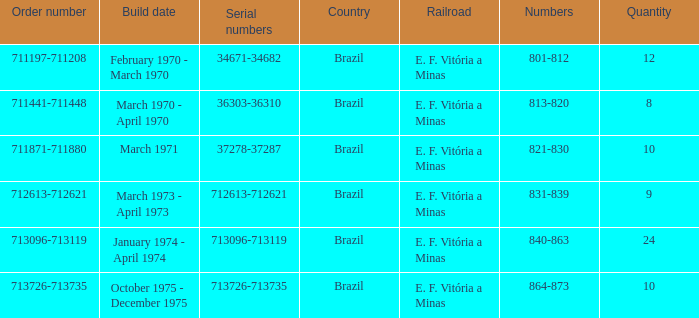The numbers 801-812 are in which country? Brazil. 